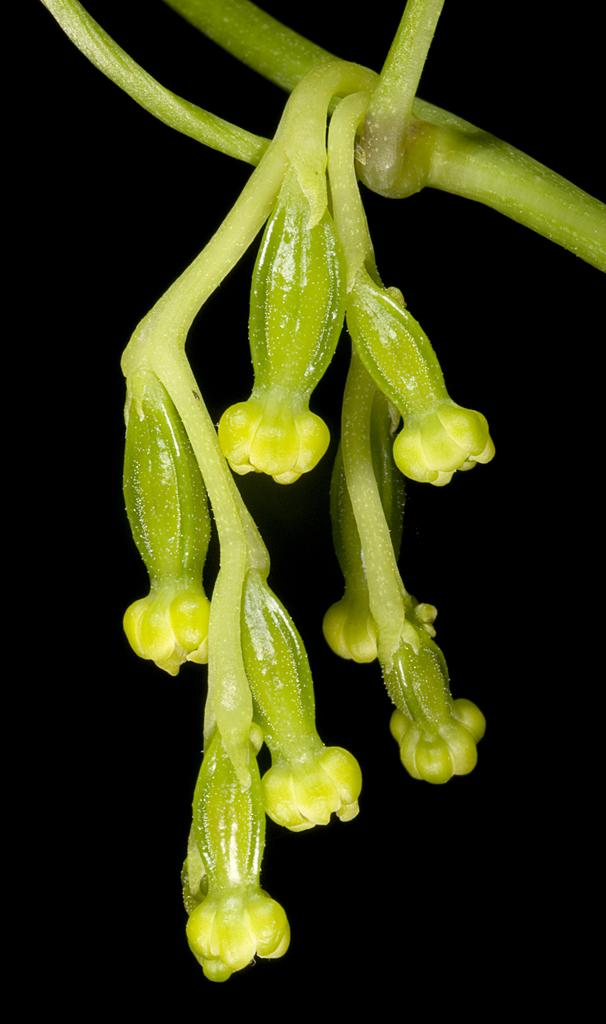What is present on the tree stem in the image? There are small buds on the tree stem in the image. What type of toys can be seen playing with the dolls in the image? There are no toys or dolls present in the image; it only features a tree stem with small buds. 